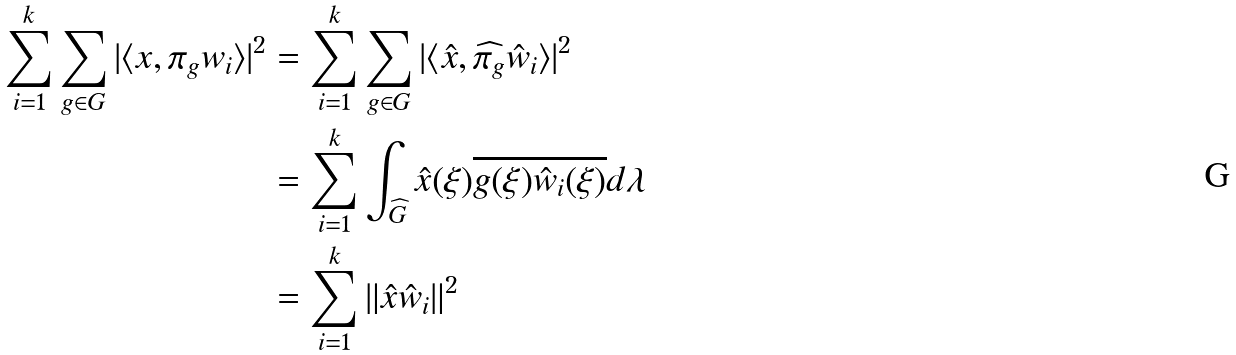Convert formula to latex. <formula><loc_0><loc_0><loc_500><loc_500>\sum _ { i = 1 } ^ { k } \sum _ { g \in G } | \langle x , \pi _ { g } w _ { i } \rangle | ^ { 2 } & = \sum _ { i = 1 } ^ { k } \sum _ { g \in G } | \langle \hat { x } , \widehat { \pi _ { g } } \hat { w } _ { i } \rangle | ^ { 2 } \\ & = \sum _ { i = 1 } ^ { k } \int _ { \widehat { G } } \hat { x } ( \xi ) \overline { g ( \xi ) \hat { w } _ { i } ( \xi ) } d \lambda \\ & = \sum _ { i = 1 } ^ { k } \| \hat { x } \hat { w } _ { i } \| ^ { 2 }</formula> 